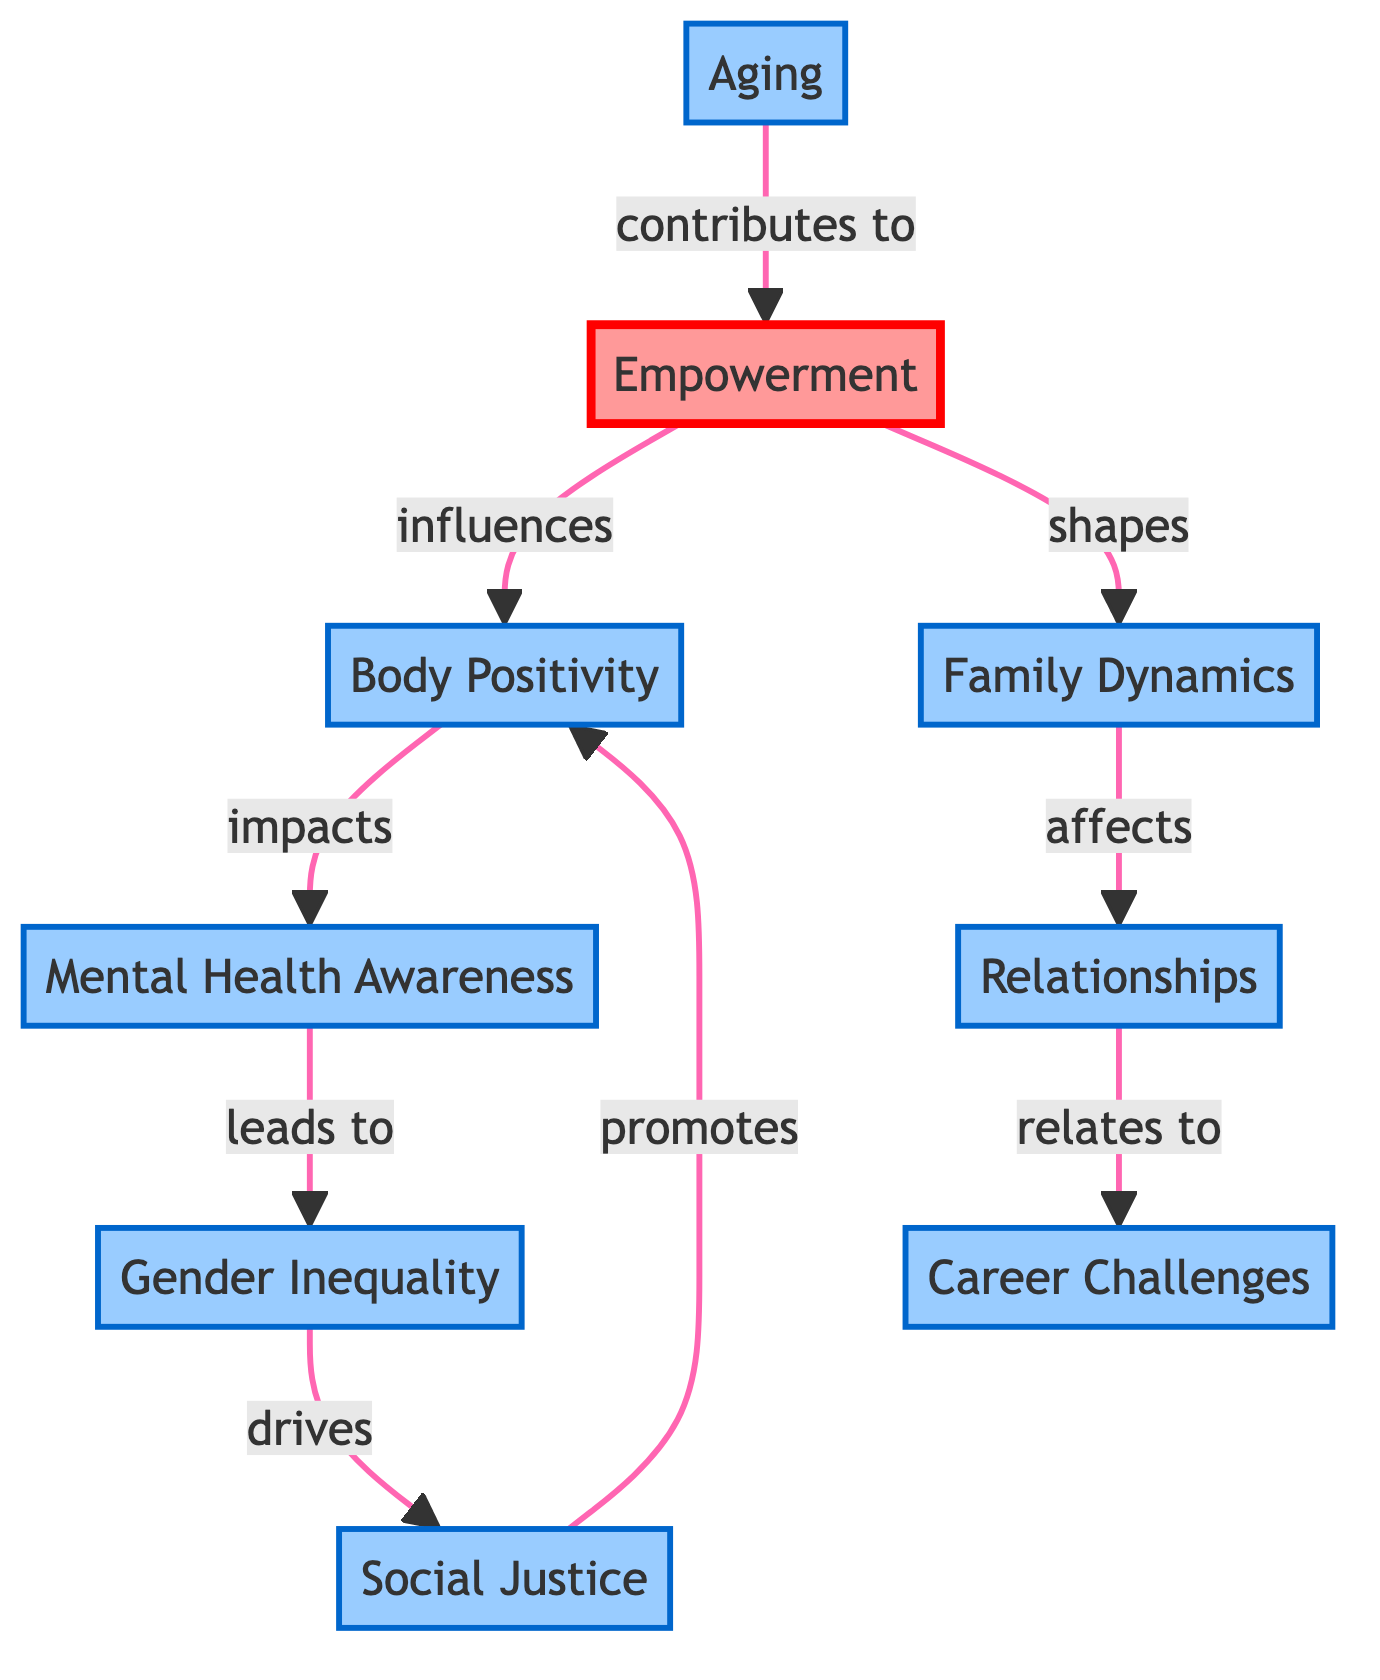What are the total number of nodes in the diagram? The diagram contains 9 nodes, which represent the key themes addressed in performances by female comediennes.
Answer: 9 Which theme influences Body Positivity? According to the edges in the diagram, Empowerment is the theme that directly influences Body Positivity.
Answer: Empowerment How many edges are connected to Gender Inequality? Gender Inequality has one outgoing edge that drives Social Justice, meaning it is connected to only one other node.
Answer: 1 What theme leads to Mental Health Awareness? The diagram shows that Body Positivity leads to Mental Health Awareness, establishing a direct connection between these two themes.
Answer: Body Positivity Which theme is influenced by Social Justice? The diagram indicates that Social Justice promotes Body Positivity, demonstrating the relationship between these two themes.
Answer: Body Positivity What is the relationship between Family Dynamics and Relationships? Family Dynamics affects Relationships, as shown by the directed edge connecting these two themes in the diagram.
Answer: affects Which two themes are influenced by Aging? Aging contributes to Empowerment, making it the only theme influenced by Aging in the diagram.
Answer: Empowerment What is the total number of directed edges in the diagram? The diagram reveals 8 directed edges connecting various themes, illustrating the flow of influence between them.
Answer: 8 How many themes relate to Career Challenges? The only theme that relates to Career Challenges is Relationships, which has a directed edge coming from it in the diagram.
Answer: 1 Which theme is directly influenced by Mental Health Awareness? The diagram shows that Mental Health Awareness leads to Gender Inequality, indicating a direct influence from one to the other.
Answer: Gender Inequality 